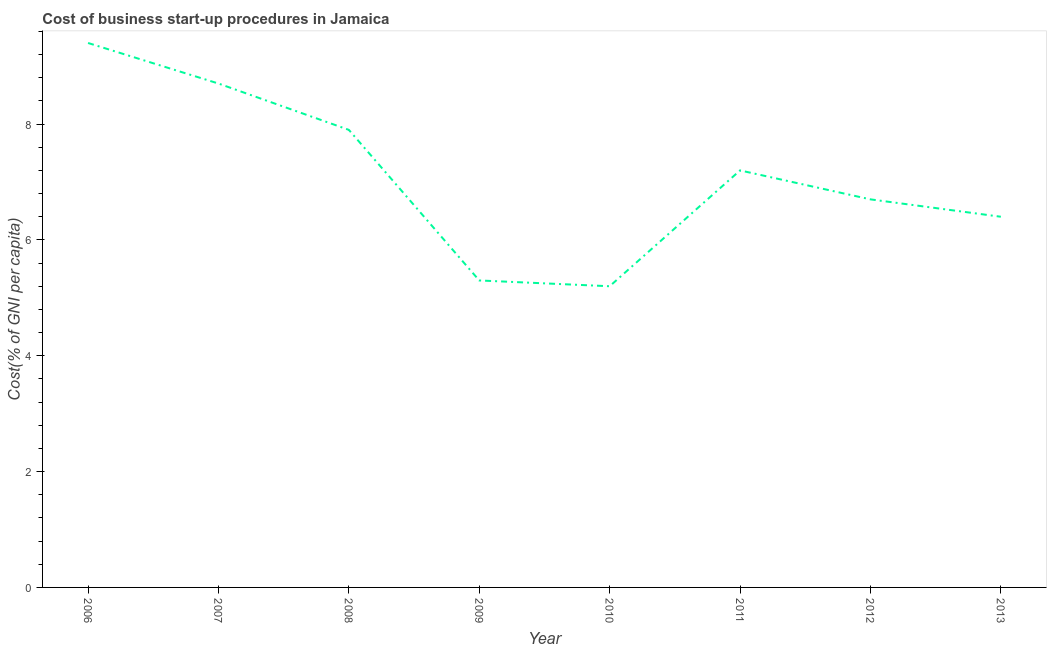What is the cost of business startup procedures in 2006?
Your answer should be very brief. 9.4. In which year was the cost of business startup procedures maximum?
Your answer should be very brief. 2006. What is the sum of the cost of business startup procedures?
Your answer should be compact. 56.8. What is the difference between the cost of business startup procedures in 2007 and 2011?
Your answer should be very brief. 1.5. What is the median cost of business startup procedures?
Your answer should be compact. 6.95. In how many years, is the cost of business startup procedures greater than 1.2000000000000002 %?
Your answer should be very brief. 8. Do a majority of the years between 2010 and 2012 (inclusive) have cost of business startup procedures greater than 8 %?
Your response must be concise. No. What is the ratio of the cost of business startup procedures in 2006 to that in 2013?
Give a very brief answer. 1.47. Is the cost of business startup procedures in 2007 less than that in 2008?
Keep it short and to the point. No. Is the difference between the cost of business startup procedures in 2006 and 2009 greater than the difference between any two years?
Ensure brevity in your answer.  No. What is the difference between the highest and the second highest cost of business startup procedures?
Keep it short and to the point. 0.7. Is the sum of the cost of business startup procedures in 2007 and 2010 greater than the maximum cost of business startup procedures across all years?
Give a very brief answer. Yes. In how many years, is the cost of business startup procedures greater than the average cost of business startup procedures taken over all years?
Provide a succinct answer. 4. How many years are there in the graph?
Offer a terse response. 8. What is the difference between two consecutive major ticks on the Y-axis?
Give a very brief answer. 2. Does the graph contain any zero values?
Ensure brevity in your answer.  No. What is the title of the graph?
Ensure brevity in your answer.  Cost of business start-up procedures in Jamaica. What is the label or title of the X-axis?
Give a very brief answer. Year. What is the label or title of the Y-axis?
Your response must be concise. Cost(% of GNI per capita). What is the Cost(% of GNI per capita) of 2009?
Provide a succinct answer. 5.3. What is the Cost(% of GNI per capita) in 2010?
Give a very brief answer. 5.2. What is the Cost(% of GNI per capita) in 2011?
Provide a succinct answer. 7.2. What is the difference between the Cost(% of GNI per capita) in 2006 and 2008?
Make the answer very short. 1.5. What is the difference between the Cost(% of GNI per capita) in 2006 and 2011?
Ensure brevity in your answer.  2.2. What is the difference between the Cost(% of GNI per capita) in 2007 and 2008?
Give a very brief answer. 0.8. What is the difference between the Cost(% of GNI per capita) in 2007 and 2009?
Ensure brevity in your answer.  3.4. What is the difference between the Cost(% of GNI per capita) in 2007 and 2010?
Offer a terse response. 3.5. What is the difference between the Cost(% of GNI per capita) in 2008 and 2010?
Provide a succinct answer. 2.7. What is the difference between the Cost(% of GNI per capita) in 2008 and 2011?
Make the answer very short. 0.7. What is the difference between the Cost(% of GNI per capita) in 2008 and 2012?
Your response must be concise. 1.2. What is the difference between the Cost(% of GNI per capita) in 2009 and 2011?
Provide a succinct answer. -1.9. What is the difference between the Cost(% of GNI per capita) in 2009 and 2012?
Provide a short and direct response. -1.4. What is the difference between the Cost(% of GNI per capita) in 2010 and 2012?
Ensure brevity in your answer.  -1.5. What is the difference between the Cost(% of GNI per capita) in 2012 and 2013?
Give a very brief answer. 0.3. What is the ratio of the Cost(% of GNI per capita) in 2006 to that in 2007?
Give a very brief answer. 1.08. What is the ratio of the Cost(% of GNI per capita) in 2006 to that in 2008?
Provide a succinct answer. 1.19. What is the ratio of the Cost(% of GNI per capita) in 2006 to that in 2009?
Your answer should be compact. 1.77. What is the ratio of the Cost(% of GNI per capita) in 2006 to that in 2010?
Your answer should be very brief. 1.81. What is the ratio of the Cost(% of GNI per capita) in 2006 to that in 2011?
Offer a terse response. 1.31. What is the ratio of the Cost(% of GNI per capita) in 2006 to that in 2012?
Your response must be concise. 1.4. What is the ratio of the Cost(% of GNI per capita) in 2006 to that in 2013?
Keep it short and to the point. 1.47. What is the ratio of the Cost(% of GNI per capita) in 2007 to that in 2008?
Make the answer very short. 1.1. What is the ratio of the Cost(% of GNI per capita) in 2007 to that in 2009?
Provide a short and direct response. 1.64. What is the ratio of the Cost(% of GNI per capita) in 2007 to that in 2010?
Your answer should be very brief. 1.67. What is the ratio of the Cost(% of GNI per capita) in 2007 to that in 2011?
Provide a short and direct response. 1.21. What is the ratio of the Cost(% of GNI per capita) in 2007 to that in 2012?
Your answer should be compact. 1.3. What is the ratio of the Cost(% of GNI per capita) in 2007 to that in 2013?
Provide a succinct answer. 1.36. What is the ratio of the Cost(% of GNI per capita) in 2008 to that in 2009?
Your answer should be compact. 1.49. What is the ratio of the Cost(% of GNI per capita) in 2008 to that in 2010?
Your answer should be very brief. 1.52. What is the ratio of the Cost(% of GNI per capita) in 2008 to that in 2011?
Give a very brief answer. 1.1. What is the ratio of the Cost(% of GNI per capita) in 2008 to that in 2012?
Ensure brevity in your answer.  1.18. What is the ratio of the Cost(% of GNI per capita) in 2008 to that in 2013?
Give a very brief answer. 1.23. What is the ratio of the Cost(% of GNI per capita) in 2009 to that in 2011?
Your answer should be compact. 0.74. What is the ratio of the Cost(% of GNI per capita) in 2009 to that in 2012?
Your response must be concise. 0.79. What is the ratio of the Cost(% of GNI per capita) in 2009 to that in 2013?
Make the answer very short. 0.83. What is the ratio of the Cost(% of GNI per capita) in 2010 to that in 2011?
Keep it short and to the point. 0.72. What is the ratio of the Cost(% of GNI per capita) in 2010 to that in 2012?
Offer a very short reply. 0.78. What is the ratio of the Cost(% of GNI per capita) in 2010 to that in 2013?
Give a very brief answer. 0.81. What is the ratio of the Cost(% of GNI per capita) in 2011 to that in 2012?
Make the answer very short. 1.07. What is the ratio of the Cost(% of GNI per capita) in 2012 to that in 2013?
Your response must be concise. 1.05. 